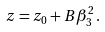<formula> <loc_0><loc_0><loc_500><loc_500>z = z _ { 0 } + B \beta _ { 3 } ^ { 2 } \, .</formula> 